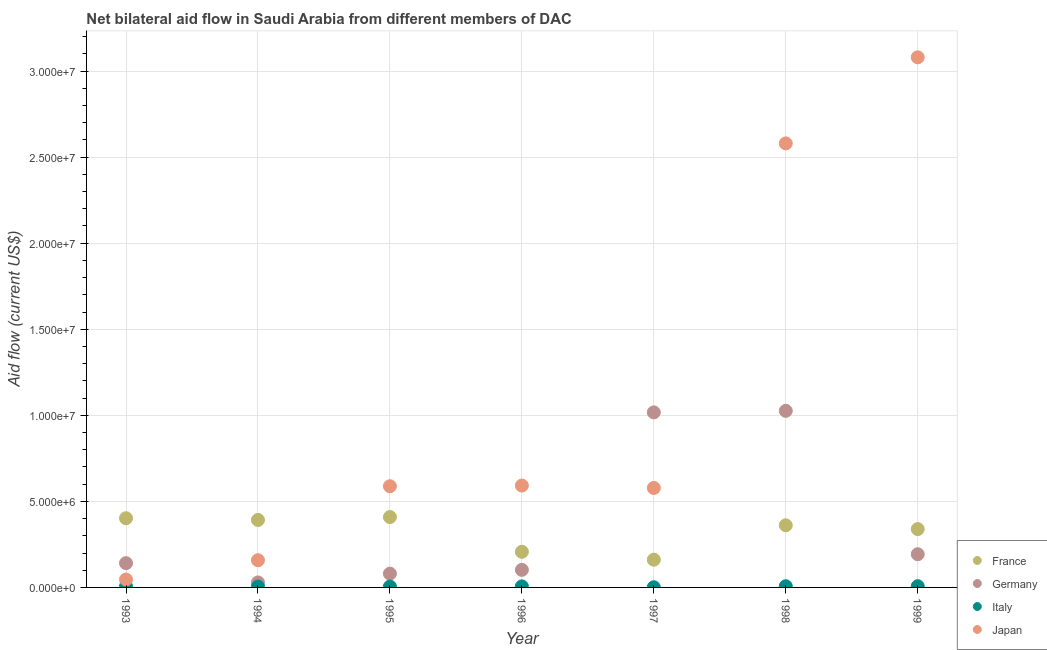How many different coloured dotlines are there?
Your response must be concise. 4. Is the number of dotlines equal to the number of legend labels?
Your answer should be very brief. Yes. What is the amount of aid given by japan in 1999?
Provide a short and direct response. 3.08e+07. Across all years, what is the maximum amount of aid given by germany?
Your answer should be very brief. 1.03e+07. Across all years, what is the minimum amount of aid given by japan?
Give a very brief answer. 4.60e+05. In which year was the amount of aid given by japan minimum?
Provide a short and direct response. 1993. What is the total amount of aid given by japan in the graph?
Ensure brevity in your answer.  7.62e+07. What is the difference between the amount of aid given by france in 1994 and that in 1997?
Give a very brief answer. 2.31e+06. What is the difference between the amount of aid given by germany in 1997 and the amount of aid given by japan in 1996?
Your answer should be compact. 4.25e+06. What is the average amount of aid given by germany per year?
Keep it short and to the point. 3.70e+06. In the year 1995, what is the difference between the amount of aid given by france and amount of aid given by germany?
Offer a very short reply. 3.29e+06. In how many years, is the amount of aid given by italy greater than 28000000 US$?
Your answer should be compact. 0. What is the ratio of the amount of aid given by france in 1995 to that in 1999?
Make the answer very short. 1.21. Is the difference between the amount of aid given by france in 1998 and 1999 greater than the difference between the amount of aid given by japan in 1998 and 1999?
Make the answer very short. Yes. What is the difference between the highest and the second highest amount of aid given by germany?
Keep it short and to the point. 9.00e+04. What is the difference between the highest and the lowest amount of aid given by france?
Offer a terse response. 2.48e+06. Is the sum of the amount of aid given by japan in 1993 and 1999 greater than the maximum amount of aid given by germany across all years?
Your response must be concise. Yes. Is it the case that in every year, the sum of the amount of aid given by germany and amount of aid given by france is greater than the sum of amount of aid given by japan and amount of aid given by italy?
Provide a succinct answer. No. Is it the case that in every year, the sum of the amount of aid given by france and amount of aid given by germany is greater than the amount of aid given by italy?
Provide a succinct answer. Yes. Is the amount of aid given by japan strictly greater than the amount of aid given by france over the years?
Make the answer very short. No. Is the amount of aid given by germany strictly less than the amount of aid given by italy over the years?
Offer a terse response. No. What is the difference between two consecutive major ticks on the Y-axis?
Ensure brevity in your answer.  5.00e+06. Are the values on the major ticks of Y-axis written in scientific E-notation?
Provide a short and direct response. Yes. Does the graph contain grids?
Give a very brief answer. Yes. How are the legend labels stacked?
Keep it short and to the point. Vertical. What is the title of the graph?
Provide a short and direct response. Net bilateral aid flow in Saudi Arabia from different members of DAC. Does "Grants and Revenue" appear as one of the legend labels in the graph?
Offer a terse response. No. What is the Aid flow (current US$) of France in 1993?
Make the answer very short. 4.02e+06. What is the Aid flow (current US$) of Germany in 1993?
Provide a short and direct response. 1.41e+06. What is the Aid flow (current US$) of Italy in 1993?
Your response must be concise. 6.00e+04. What is the Aid flow (current US$) in France in 1994?
Give a very brief answer. 3.92e+06. What is the Aid flow (current US$) in Italy in 1994?
Make the answer very short. 5.00e+04. What is the Aid flow (current US$) of Japan in 1994?
Your response must be concise. 1.58e+06. What is the Aid flow (current US$) of France in 1995?
Your response must be concise. 4.09e+06. What is the Aid flow (current US$) in Japan in 1995?
Make the answer very short. 5.88e+06. What is the Aid flow (current US$) of France in 1996?
Your answer should be compact. 2.07e+06. What is the Aid flow (current US$) in Germany in 1996?
Your answer should be very brief. 1.02e+06. What is the Aid flow (current US$) in Japan in 1996?
Ensure brevity in your answer.  5.92e+06. What is the Aid flow (current US$) of France in 1997?
Offer a very short reply. 1.61e+06. What is the Aid flow (current US$) in Germany in 1997?
Make the answer very short. 1.02e+07. What is the Aid flow (current US$) in Japan in 1997?
Keep it short and to the point. 5.78e+06. What is the Aid flow (current US$) in France in 1998?
Provide a succinct answer. 3.61e+06. What is the Aid flow (current US$) in Germany in 1998?
Give a very brief answer. 1.03e+07. What is the Aid flow (current US$) in Italy in 1998?
Give a very brief answer. 7.00e+04. What is the Aid flow (current US$) in Japan in 1998?
Your answer should be compact. 2.58e+07. What is the Aid flow (current US$) of France in 1999?
Your answer should be very brief. 3.39e+06. What is the Aid flow (current US$) in Germany in 1999?
Your answer should be very brief. 1.93e+06. What is the Aid flow (current US$) in Italy in 1999?
Make the answer very short. 7.00e+04. What is the Aid flow (current US$) of Japan in 1999?
Your response must be concise. 3.08e+07. Across all years, what is the maximum Aid flow (current US$) in France?
Make the answer very short. 4.09e+06. Across all years, what is the maximum Aid flow (current US$) of Germany?
Keep it short and to the point. 1.03e+07. Across all years, what is the maximum Aid flow (current US$) in Italy?
Keep it short and to the point. 7.00e+04. Across all years, what is the maximum Aid flow (current US$) in Japan?
Provide a short and direct response. 3.08e+07. Across all years, what is the minimum Aid flow (current US$) in France?
Give a very brief answer. 1.61e+06. Across all years, what is the minimum Aid flow (current US$) of Germany?
Offer a very short reply. 2.90e+05. Across all years, what is the minimum Aid flow (current US$) of Japan?
Offer a terse response. 4.60e+05. What is the total Aid flow (current US$) in France in the graph?
Offer a terse response. 2.27e+07. What is the total Aid flow (current US$) in Germany in the graph?
Provide a short and direct response. 2.59e+07. What is the total Aid flow (current US$) of Japan in the graph?
Your answer should be compact. 7.62e+07. What is the difference between the Aid flow (current US$) of France in 1993 and that in 1994?
Your answer should be compact. 1.00e+05. What is the difference between the Aid flow (current US$) of Germany in 1993 and that in 1994?
Your answer should be compact. 1.12e+06. What is the difference between the Aid flow (current US$) in Italy in 1993 and that in 1994?
Keep it short and to the point. 10000. What is the difference between the Aid flow (current US$) of Japan in 1993 and that in 1994?
Keep it short and to the point. -1.12e+06. What is the difference between the Aid flow (current US$) in France in 1993 and that in 1995?
Make the answer very short. -7.00e+04. What is the difference between the Aid flow (current US$) of Germany in 1993 and that in 1995?
Your answer should be very brief. 6.10e+05. What is the difference between the Aid flow (current US$) in Italy in 1993 and that in 1995?
Make the answer very short. 10000. What is the difference between the Aid flow (current US$) in Japan in 1993 and that in 1995?
Give a very brief answer. -5.42e+06. What is the difference between the Aid flow (current US$) in France in 1993 and that in 1996?
Provide a short and direct response. 1.95e+06. What is the difference between the Aid flow (current US$) in Germany in 1993 and that in 1996?
Make the answer very short. 3.90e+05. What is the difference between the Aid flow (current US$) in Japan in 1993 and that in 1996?
Your answer should be compact. -5.46e+06. What is the difference between the Aid flow (current US$) in France in 1993 and that in 1997?
Your response must be concise. 2.41e+06. What is the difference between the Aid flow (current US$) of Germany in 1993 and that in 1997?
Your answer should be very brief. -8.76e+06. What is the difference between the Aid flow (current US$) of Japan in 1993 and that in 1997?
Your response must be concise. -5.32e+06. What is the difference between the Aid flow (current US$) of France in 1993 and that in 1998?
Give a very brief answer. 4.10e+05. What is the difference between the Aid flow (current US$) in Germany in 1993 and that in 1998?
Give a very brief answer. -8.85e+06. What is the difference between the Aid flow (current US$) of Italy in 1993 and that in 1998?
Ensure brevity in your answer.  -10000. What is the difference between the Aid flow (current US$) in Japan in 1993 and that in 1998?
Provide a short and direct response. -2.53e+07. What is the difference between the Aid flow (current US$) in France in 1993 and that in 1999?
Provide a succinct answer. 6.30e+05. What is the difference between the Aid flow (current US$) in Germany in 1993 and that in 1999?
Your answer should be compact. -5.20e+05. What is the difference between the Aid flow (current US$) of Italy in 1993 and that in 1999?
Keep it short and to the point. -10000. What is the difference between the Aid flow (current US$) in Japan in 1993 and that in 1999?
Your response must be concise. -3.03e+07. What is the difference between the Aid flow (current US$) of Germany in 1994 and that in 1995?
Make the answer very short. -5.10e+05. What is the difference between the Aid flow (current US$) of Japan in 1994 and that in 1995?
Your answer should be very brief. -4.30e+06. What is the difference between the Aid flow (current US$) in France in 1994 and that in 1996?
Offer a terse response. 1.85e+06. What is the difference between the Aid flow (current US$) in Germany in 1994 and that in 1996?
Give a very brief answer. -7.30e+05. What is the difference between the Aid flow (current US$) in Japan in 1994 and that in 1996?
Provide a succinct answer. -4.34e+06. What is the difference between the Aid flow (current US$) of France in 1994 and that in 1997?
Your response must be concise. 2.31e+06. What is the difference between the Aid flow (current US$) of Germany in 1994 and that in 1997?
Offer a terse response. -9.88e+06. What is the difference between the Aid flow (current US$) in Italy in 1994 and that in 1997?
Your response must be concise. 4.00e+04. What is the difference between the Aid flow (current US$) of Japan in 1994 and that in 1997?
Make the answer very short. -4.20e+06. What is the difference between the Aid flow (current US$) in France in 1994 and that in 1998?
Make the answer very short. 3.10e+05. What is the difference between the Aid flow (current US$) in Germany in 1994 and that in 1998?
Provide a succinct answer. -9.97e+06. What is the difference between the Aid flow (current US$) of Italy in 1994 and that in 1998?
Your answer should be very brief. -2.00e+04. What is the difference between the Aid flow (current US$) in Japan in 1994 and that in 1998?
Ensure brevity in your answer.  -2.42e+07. What is the difference between the Aid flow (current US$) of France in 1994 and that in 1999?
Your response must be concise. 5.30e+05. What is the difference between the Aid flow (current US$) in Germany in 1994 and that in 1999?
Offer a very short reply. -1.64e+06. What is the difference between the Aid flow (current US$) in Japan in 1994 and that in 1999?
Make the answer very short. -2.92e+07. What is the difference between the Aid flow (current US$) in France in 1995 and that in 1996?
Ensure brevity in your answer.  2.02e+06. What is the difference between the Aid flow (current US$) in Germany in 1995 and that in 1996?
Your answer should be very brief. -2.20e+05. What is the difference between the Aid flow (current US$) in Italy in 1995 and that in 1996?
Offer a terse response. -10000. What is the difference between the Aid flow (current US$) of France in 1995 and that in 1997?
Your response must be concise. 2.48e+06. What is the difference between the Aid flow (current US$) of Germany in 1995 and that in 1997?
Provide a short and direct response. -9.37e+06. What is the difference between the Aid flow (current US$) in France in 1995 and that in 1998?
Your response must be concise. 4.80e+05. What is the difference between the Aid flow (current US$) of Germany in 1995 and that in 1998?
Your answer should be compact. -9.46e+06. What is the difference between the Aid flow (current US$) of Italy in 1995 and that in 1998?
Your answer should be very brief. -2.00e+04. What is the difference between the Aid flow (current US$) in Japan in 1995 and that in 1998?
Offer a very short reply. -1.99e+07. What is the difference between the Aid flow (current US$) in France in 1995 and that in 1999?
Ensure brevity in your answer.  7.00e+05. What is the difference between the Aid flow (current US$) of Germany in 1995 and that in 1999?
Provide a short and direct response. -1.13e+06. What is the difference between the Aid flow (current US$) in Italy in 1995 and that in 1999?
Give a very brief answer. -2.00e+04. What is the difference between the Aid flow (current US$) in Japan in 1995 and that in 1999?
Make the answer very short. -2.49e+07. What is the difference between the Aid flow (current US$) in Germany in 1996 and that in 1997?
Offer a terse response. -9.15e+06. What is the difference between the Aid flow (current US$) in Italy in 1996 and that in 1997?
Your answer should be very brief. 5.00e+04. What is the difference between the Aid flow (current US$) of France in 1996 and that in 1998?
Ensure brevity in your answer.  -1.54e+06. What is the difference between the Aid flow (current US$) in Germany in 1996 and that in 1998?
Your answer should be very brief. -9.24e+06. What is the difference between the Aid flow (current US$) of Japan in 1996 and that in 1998?
Your response must be concise. -1.99e+07. What is the difference between the Aid flow (current US$) in France in 1996 and that in 1999?
Ensure brevity in your answer.  -1.32e+06. What is the difference between the Aid flow (current US$) in Germany in 1996 and that in 1999?
Offer a terse response. -9.10e+05. What is the difference between the Aid flow (current US$) in Japan in 1996 and that in 1999?
Offer a terse response. -2.49e+07. What is the difference between the Aid flow (current US$) in France in 1997 and that in 1998?
Provide a succinct answer. -2.00e+06. What is the difference between the Aid flow (current US$) in Germany in 1997 and that in 1998?
Your answer should be very brief. -9.00e+04. What is the difference between the Aid flow (current US$) in Italy in 1997 and that in 1998?
Your answer should be very brief. -6.00e+04. What is the difference between the Aid flow (current US$) of Japan in 1997 and that in 1998?
Offer a very short reply. -2.00e+07. What is the difference between the Aid flow (current US$) of France in 1997 and that in 1999?
Your answer should be very brief. -1.78e+06. What is the difference between the Aid flow (current US$) in Germany in 1997 and that in 1999?
Your answer should be very brief. 8.24e+06. What is the difference between the Aid flow (current US$) of Japan in 1997 and that in 1999?
Your answer should be very brief. -2.50e+07. What is the difference between the Aid flow (current US$) of France in 1998 and that in 1999?
Give a very brief answer. 2.20e+05. What is the difference between the Aid flow (current US$) of Germany in 1998 and that in 1999?
Give a very brief answer. 8.33e+06. What is the difference between the Aid flow (current US$) of Japan in 1998 and that in 1999?
Your response must be concise. -5.00e+06. What is the difference between the Aid flow (current US$) in France in 1993 and the Aid flow (current US$) in Germany in 1994?
Ensure brevity in your answer.  3.73e+06. What is the difference between the Aid flow (current US$) in France in 1993 and the Aid flow (current US$) in Italy in 1994?
Offer a very short reply. 3.97e+06. What is the difference between the Aid flow (current US$) of France in 1993 and the Aid flow (current US$) of Japan in 1994?
Your answer should be compact. 2.44e+06. What is the difference between the Aid flow (current US$) in Germany in 1993 and the Aid flow (current US$) in Italy in 1994?
Ensure brevity in your answer.  1.36e+06. What is the difference between the Aid flow (current US$) of Germany in 1993 and the Aid flow (current US$) of Japan in 1994?
Make the answer very short. -1.70e+05. What is the difference between the Aid flow (current US$) in Italy in 1993 and the Aid flow (current US$) in Japan in 1994?
Your response must be concise. -1.52e+06. What is the difference between the Aid flow (current US$) of France in 1993 and the Aid flow (current US$) of Germany in 1995?
Your answer should be very brief. 3.22e+06. What is the difference between the Aid flow (current US$) in France in 1993 and the Aid flow (current US$) in Italy in 1995?
Your answer should be very brief. 3.97e+06. What is the difference between the Aid flow (current US$) in France in 1993 and the Aid flow (current US$) in Japan in 1995?
Offer a terse response. -1.86e+06. What is the difference between the Aid flow (current US$) in Germany in 1993 and the Aid flow (current US$) in Italy in 1995?
Offer a very short reply. 1.36e+06. What is the difference between the Aid flow (current US$) in Germany in 1993 and the Aid flow (current US$) in Japan in 1995?
Your answer should be very brief. -4.47e+06. What is the difference between the Aid flow (current US$) of Italy in 1993 and the Aid flow (current US$) of Japan in 1995?
Provide a succinct answer. -5.82e+06. What is the difference between the Aid flow (current US$) in France in 1993 and the Aid flow (current US$) in Italy in 1996?
Offer a very short reply. 3.96e+06. What is the difference between the Aid flow (current US$) in France in 1993 and the Aid flow (current US$) in Japan in 1996?
Provide a succinct answer. -1.90e+06. What is the difference between the Aid flow (current US$) in Germany in 1993 and the Aid flow (current US$) in Italy in 1996?
Ensure brevity in your answer.  1.35e+06. What is the difference between the Aid flow (current US$) of Germany in 1993 and the Aid flow (current US$) of Japan in 1996?
Offer a very short reply. -4.51e+06. What is the difference between the Aid flow (current US$) in Italy in 1993 and the Aid flow (current US$) in Japan in 1996?
Provide a succinct answer. -5.86e+06. What is the difference between the Aid flow (current US$) of France in 1993 and the Aid flow (current US$) of Germany in 1997?
Keep it short and to the point. -6.15e+06. What is the difference between the Aid flow (current US$) in France in 1993 and the Aid flow (current US$) in Italy in 1997?
Keep it short and to the point. 4.01e+06. What is the difference between the Aid flow (current US$) in France in 1993 and the Aid flow (current US$) in Japan in 1997?
Keep it short and to the point. -1.76e+06. What is the difference between the Aid flow (current US$) in Germany in 1993 and the Aid flow (current US$) in Italy in 1997?
Your answer should be very brief. 1.40e+06. What is the difference between the Aid flow (current US$) of Germany in 1993 and the Aid flow (current US$) of Japan in 1997?
Your answer should be very brief. -4.37e+06. What is the difference between the Aid flow (current US$) in Italy in 1993 and the Aid flow (current US$) in Japan in 1997?
Keep it short and to the point. -5.72e+06. What is the difference between the Aid flow (current US$) of France in 1993 and the Aid flow (current US$) of Germany in 1998?
Offer a terse response. -6.24e+06. What is the difference between the Aid flow (current US$) in France in 1993 and the Aid flow (current US$) in Italy in 1998?
Provide a short and direct response. 3.95e+06. What is the difference between the Aid flow (current US$) of France in 1993 and the Aid flow (current US$) of Japan in 1998?
Offer a very short reply. -2.18e+07. What is the difference between the Aid flow (current US$) of Germany in 1993 and the Aid flow (current US$) of Italy in 1998?
Ensure brevity in your answer.  1.34e+06. What is the difference between the Aid flow (current US$) of Germany in 1993 and the Aid flow (current US$) of Japan in 1998?
Make the answer very short. -2.44e+07. What is the difference between the Aid flow (current US$) of Italy in 1993 and the Aid flow (current US$) of Japan in 1998?
Give a very brief answer. -2.57e+07. What is the difference between the Aid flow (current US$) in France in 1993 and the Aid flow (current US$) in Germany in 1999?
Provide a short and direct response. 2.09e+06. What is the difference between the Aid flow (current US$) of France in 1993 and the Aid flow (current US$) of Italy in 1999?
Offer a very short reply. 3.95e+06. What is the difference between the Aid flow (current US$) in France in 1993 and the Aid flow (current US$) in Japan in 1999?
Provide a short and direct response. -2.68e+07. What is the difference between the Aid flow (current US$) in Germany in 1993 and the Aid flow (current US$) in Italy in 1999?
Your answer should be compact. 1.34e+06. What is the difference between the Aid flow (current US$) in Germany in 1993 and the Aid flow (current US$) in Japan in 1999?
Your response must be concise. -2.94e+07. What is the difference between the Aid flow (current US$) of Italy in 1993 and the Aid flow (current US$) of Japan in 1999?
Offer a terse response. -3.07e+07. What is the difference between the Aid flow (current US$) of France in 1994 and the Aid flow (current US$) of Germany in 1995?
Provide a succinct answer. 3.12e+06. What is the difference between the Aid flow (current US$) of France in 1994 and the Aid flow (current US$) of Italy in 1995?
Provide a short and direct response. 3.87e+06. What is the difference between the Aid flow (current US$) in France in 1994 and the Aid flow (current US$) in Japan in 1995?
Your response must be concise. -1.96e+06. What is the difference between the Aid flow (current US$) of Germany in 1994 and the Aid flow (current US$) of Japan in 1995?
Ensure brevity in your answer.  -5.59e+06. What is the difference between the Aid flow (current US$) of Italy in 1994 and the Aid flow (current US$) of Japan in 1995?
Give a very brief answer. -5.83e+06. What is the difference between the Aid flow (current US$) of France in 1994 and the Aid flow (current US$) of Germany in 1996?
Offer a very short reply. 2.90e+06. What is the difference between the Aid flow (current US$) of France in 1994 and the Aid flow (current US$) of Italy in 1996?
Keep it short and to the point. 3.86e+06. What is the difference between the Aid flow (current US$) in France in 1994 and the Aid flow (current US$) in Japan in 1996?
Keep it short and to the point. -2.00e+06. What is the difference between the Aid flow (current US$) of Germany in 1994 and the Aid flow (current US$) of Italy in 1996?
Give a very brief answer. 2.30e+05. What is the difference between the Aid flow (current US$) of Germany in 1994 and the Aid flow (current US$) of Japan in 1996?
Keep it short and to the point. -5.63e+06. What is the difference between the Aid flow (current US$) of Italy in 1994 and the Aid flow (current US$) of Japan in 1996?
Your answer should be compact. -5.87e+06. What is the difference between the Aid flow (current US$) of France in 1994 and the Aid flow (current US$) of Germany in 1997?
Your answer should be compact. -6.25e+06. What is the difference between the Aid flow (current US$) in France in 1994 and the Aid flow (current US$) in Italy in 1997?
Provide a succinct answer. 3.91e+06. What is the difference between the Aid flow (current US$) in France in 1994 and the Aid flow (current US$) in Japan in 1997?
Offer a very short reply. -1.86e+06. What is the difference between the Aid flow (current US$) of Germany in 1994 and the Aid flow (current US$) of Italy in 1997?
Your response must be concise. 2.80e+05. What is the difference between the Aid flow (current US$) of Germany in 1994 and the Aid flow (current US$) of Japan in 1997?
Keep it short and to the point. -5.49e+06. What is the difference between the Aid flow (current US$) in Italy in 1994 and the Aid flow (current US$) in Japan in 1997?
Provide a succinct answer. -5.73e+06. What is the difference between the Aid flow (current US$) of France in 1994 and the Aid flow (current US$) of Germany in 1998?
Give a very brief answer. -6.34e+06. What is the difference between the Aid flow (current US$) of France in 1994 and the Aid flow (current US$) of Italy in 1998?
Offer a terse response. 3.85e+06. What is the difference between the Aid flow (current US$) in France in 1994 and the Aid flow (current US$) in Japan in 1998?
Give a very brief answer. -2.19e+07. What is the difference between the Aid flow (current US$) in Germany in 1994 and the Aid flow (current US$) in Japan in 1998?
Your answer should be very brief. -2.55e+07. What is the difference between the Aid flow (current US$) in Italy in 1994 and the Aid flow (current US$) in Japan in 1998?
Keep it short and to the point. -2.58e+07. What is the difference between the Aid flow (current US$) of France in 1994 and the Aid flow (current US$) of Germany in 1999?
Offer a terse response. 1.99e+06. What is the difference between the Aid flow (current US$) of France in 1994 and the Aid flow (current US$) of Italy in 1999?
Ensure brevity in your answer.  3.85e+06. What is the difference between the Aid flow (current US$) of France in 1994 and the Aid flow (current US$) of Japan in 1999?
Make the answer very short. -2.69e+07. What is the difference between the Aid flow (current US$) in Germany in 1994 and the Aid flow (current US$) in Japan in 1999?
Provide a succinct answer. -3.05e+07. What is the difference between the Aid flow (current US$) in Italy in 1994 and the Aid flow (current US$) in Japan in 1999?
Your response must be concise. -3.08e+07. What is the difference between the Aid flow (current US$) of France in 1995 and the Aid flow (current US$) of Germany in 1996?
Make the answer very short. 3.07e+06. What is the difference between the Aid flow (current US$) in France in 1995 and the Aid flow (current US$) in Italy in 1996?
Your answer should be compact. 4.03e+06. What is the difference between the Aid flow (current US$) of France in 1995 and the Aid flow (current US$) of Japan in 1996?
Ensure brevity in your answer.  -1.83e+06. What is the difference between the Aid flow (current US$) of Germany in 1995 and the Aid flow (current US$) of Italy in 1996?
Your response must be concise. 7.40e+05. What is the difference between the Aid flow (current US$) of Germany in 1995 and the Aid flow (current US$) of Japan in 1996?
Ensure brevity in your answer.  -5.12e+06. What is the difference between the Aid flow (current US$) in Italy in 1995 and the Aid flow (current US$) in Japan in 1996?
Offer a very short reply. -5.87e+06. What is the difference between the Aid flow (current US$) of France in 1995 and the Aid flow (current US$) of Germany in 1997?
Provide a short and direct response. -6.08e+06. What is the difference between the Aid flow (current US$) in France in 1995 and the Aid flow (current US$) in Italy in 1997?
Ensure brevity in your answer.  4.08e+06. What is the difference between the Aid flow (current US$) in France in 1995 and the Aid flow (current US$) in Japan in 1997?
Ensure brevity in your answer.  -1.69e+06. What is the difference between the Aid flow (current US$) of Germany in 1995 and the Aid flow (current US$) of Italy in 1997?
Keep it short and to the point. 7.90e+05. What is the difference between the Aid flow (current US$) in Germany in 1995 and the Aid flow (current US$) in Japan in 1997?
Make the answer very short. -4.98e+06. What is the difference between the Aid flow (current US$) of Italy in 1995 and the Aid flow (current US$) of Japan in 1997?
Offer a very short reply. -5.73e+06. What is the difference between the Aid flow (current US$) of France in 1995 and the Aid flow (current US$) of Germany in 1998?
Offer a terse response. -6.17e+06. What is the difference between the Aid flow (current US$) in France in 1995 and the Aid flow (current US$) in Italy in 1998?
Provide a succinct answer. 4.02e+06. What is the difference between the Aid flow (current US$) of France in 1995 and the Aid flow (current US$) of Japan in 1998?
Your response must be concise. -2.17e+07. What is the difference between the Aid flow (current US$) in Germany in 1995 and the Aid flow (current US$) in Italy in 1998?
Your answer should be compact. 7.30e+05. What is the difference between the Aid flow (current US$) in Germany in 1995 and the Aid flow (current US$) in Japan in 1998?
Ensure brevity in your answer.  -2.50e+07. What is the difference between the Aid flow (current US$) of Italy in 1995 and the Aid flow (current US$) of Japan in 1998?
Your answer should be compact. -2.58e+07. What is the difference between the Aid flow (current US$) in France in 1995 and the Aid flow (current US$) in Germany in 1999?
Make the answer very short. 2.16e+06. What is the difference between the Aid flow (current US$) in France in 1995 and the Aid flow (current US$) in Italy in 1999?
Your response must be concise. 4.02e+06. What is the difference between the Aid flow (current US$) in France in 1995 and the Aid flow (current US$) in Japan in 1999?
Keep it short and to the point. -2.67e+07. What is the difference between the Aid flow (current US$) in Germany in 1995 and the Aid flow (current US$) in Italy in 1999?
Provide a succinct answer. 7.30e+05. What is the difference between the Aid flow (current US$) in Germany in 1995 and the Aid flow (current US$) in Japan in 1999?
Ensure brevity in your answer.  -3.00e+07. What is the difference between the Aid flow (current US$) of Italy in 1995 and the Aid flow (current US$) of Japan in 1999?
Make the answer very short. -3.08e+07. What is the difference between the Aid flow (current US$) in France in 1996 and the Aid flow (current US$) in Germany in 1997?
Give a very brief answer. -8.10e+06. What is the difference between the Aid flow (current US$) in France in 1996 and the Aid flow (current US$) in Italy in 1997?
Your answer should be compact. 2.06e+06. What is the difference between the Aid flow (current US$) of France in 1996 and the Aid flow (current US$) of Japan in 1997?
Your response must be concise. -3.71e+06. What is the difference between the Aid flow (current US$) of Germany in 1996 and the Aid flow (current US$) of Italy in 1997?
Ensure brevity in your answer.  1.01e+06. What is the difference between the Aid flow (current US$) in Germany in 1996 and the Aid flow (current US$) in Japan in 1997?
Provide a short and direct response. -4.76e+06. What is the difference between the Aid flow (current US$) in Italy in 1996 and the Aid flow (current US$) in Japan in 1997?
Offer a terse response. -5.72e+06. What is the difference between the Aid flow (current US$) of France in 1996 and the Aid flow (current US$) of Germany in 1998?
Keep it short and to the point. -8.19e+06. What is the difference between the Aid flow (current US$) in France in 1996 and the Aid flow (current US$) in Japan in 1998?
Ensure brevity in your answer.  -2.37e+07. What is the difference between the Aid flow (current US$) in Germany in 1996 and the Aid flow (current US$) in Italy in 1998?
Keep it short and to the point. 9.50e+05. What is the difference between the Aid flow (current US$) of Germany in 1996 and the Aid flow (current US$) of Japan in 1998?
Offer a very short reply. -2.48e+07. What is the difference between the Aid flow (current US$) in Italy in 1996 and the Aid flow (current US$) in Japan in 1998?
Ensure brevity in your answer.  -2.57e+07. What is the difference between the Aid flow (current US$) of France in 1996 and the Aid flow (current US$) of Italy in 1999?
Your answer should be very brief. 2.00e+06. What is the difference between the Aid flow (current US$) in France in 1996 and the Aid flow (current US$) in Japan in 1999?
Offer a very short reply. -2.87e+07. What is the difference between the Aid flow (current US$) in Germany in 1996 and the Aid flow (current US$) in Italy in 1999?
Your answer should be compact. 9.50e+05. What is the difference between the Aid flow (current US$) in Germany in 1996 and the Aid flow (current US$) in Japan in 1999?
Give a very brief answer. -2.98e+07. What is the difference between the Aid flow (current US$) in Italy in 1996 and the Aid flow (current US$) in Japan in 1999?
Your answer should be compact. -3.07e+07. What is the difference between the Aid flow (current US$) in France in 1997 and the Aid flow (current US$) in Germany in 1998?
Your answer should be compact. -8.65e+06. What is the difference between the Aid flow (current US$) of France in 1997 and the Aid flow (current US$) of Italy in 1998?
Offer a terse response. 1.54e+06. What is the difference between the Aid flow (current US$) in France in 1997 and the Aid flow (current US$) in Japan in 1998?
Your answer should be compact. -2.42e+07. What is the difference between the Aid flow (current US$) of Germany in 1997 and the Aid flow (current US$) of Italy in 1998?
Keep it short and to the point. 1.01e+07. What is the difference between the Aid flow (current US$) in Germany in 1997 and the Aid flow (current US$) in Japan in 1998?
Provide a succinct answer. -1.56e+07. What is the difference between the Aid flow (current US$) of Italy in 1997 and the Aid flow (current US$) of Japan in 1998?
Ensure brevity in your answer.  -2.58e+07. What is the difference between the Aid flow (current US$) of France in 1997 and the Aid flow (current US$) of Germany in 1999?
Ensure brevity in your answer.  -3.20e+05. What is the difference between the Aid flow (current US$) in France in 1997 and the Aid flow (current US$) in Italy in 1999?
Your answer should be very brief. 1.54e+06. What is the difference between the Aid flow (current US$) in France in 1997 and the Aid flow (current US$) in Japan in 1999?
Make the answer very short. -2.92e+07. What is the difference between the Aid flow (current US$) of Germany in 1997 and the Aid flow (current US$) of Italy in 1999?
Keep it short and to the point. 1.01e+07. What is the difference between the Aid flow (current US$) in Germany in 1997 and the Aid flow (current US$) in Japan in 1999?
Provide a succinct answer. -2.06e+07. What is the difference between the Aid flow (current US$) of Italy in 1997 and the Aid flow (current US$) of Japan in 1999?
Make the answer very short. -3.08e+07. What is the difference between the Aid flow (current US$) of France in 1998 and the Aid flow (current US$) of Germany in 1999?
Provide a short and direct response. 1.68e+06. What is the difference between the Aid flow (current US$) in France in 1998 and the Aid flow (current US$) in Italy in 1999?
Make the answer very short. 3.54e+06. What is the difference between the Aid flow (current US$) of France in 1998 and the Aid flow (current US$) of Japan in 1999?
Provide a short and direct response. -2.72e+07. What is the difference between the Aid flow (current US$) in Germany in 1998 and the Aid flow (current US$) in Italy in 1999?
Your answer should be very brief. 1.02e+07. What is the difference between the Aid flow (current US$) in Germany in 1998 and the Aid flow (current US$) in Japan in 1999?
Your response must be concise. -2.05e+07. What is the difference between the Aid flow (current US$) in Italy in 1998 and the Aid flow (current US$) in Japan in 1999?
Ensure brevity in your answer.  -3.07e+07. What is the average Aid flow (current US$) in France per year?
Give a very brief answer. 3.24e+06. What is the average Aid flow (current US$) of Germany per year?
Make the answer very short. 3.70e+06. What is the average Aid flow (current US$) of Italy per year?
Provide a succinct answer. 5.29e+04. What is the average Aid flow (current US$) of Japan per year?
Offer a very short reply. 1.09e+07. In the year 1993, what is the difference between the Aid flow (current US$) in France and Aid flow (current US$) in Germany?
Ensure brevity in your answer.  2.61e+06. In the year 1993, what is the difference between the Aid flow (current US$) in France and Aid flow (current US$) in Italy?
Provide a short and direct response. 3.96e+06. In the year 1993, what is the difference between the Aid flow (current US$) of France and Aid flow (current US$) of Japan?
Offer a terse response. 3.56e+06. In the year 1993, what is the difference between the Aid flow (current US$) of Germany and Aid flow (current US$) of Italy?
Offer a terse response. 1.35e+06. In the year 1993, what is the difference between the Aid flow (current US$) in Germany and Aid flow (current US$) in Japan?
Make the answer very short. 9.50e+05. In the year 1993, what is the difference between the Aid flow (current US$) in Italy and Aid flow (current US$) in Japan?
Your response must be concise. -4.00e+05. In the year 1994, what is the difference between the Aid flow (current US$) in France and Aid flow (current US$) in Germany?
Your answer should be compact. 3.63e+06. In the year 1994, what is the difference between the Aid flow (current US$) of France and Aid flow (current US$) of Italy?
Your answer should be very brief. 3.87e+06. In the year 1994, what is the difference between the Aid flow (current US$) in France and Aid flow (current US$) in Japan?
Provide a short and direct response. 2.34e+06. In the year 1994, what is the difference between the Aid flow (current US$) of Germany and Aid flow (current US$) of Italy?
Your answer should be compact. 2.40e+05. In the year 1994, what is the difference between the Aid flow (current US$) in Germany and Aid flow (current US$) in Japan?
Give a very brief answer. -1.29e+06. In the year 1994, what is the difference between the Aid flow (current US$) of Italy and Aid flow (current US$) of Japan?
Offer a terse response. -1.53e+06. In the year 1995, what is the difference between the Aid flow (current US$) in France and Aid flow (current US$) in Germany?
Your response must be concise. 3.29e+06. In the year 1995, what is the difference between the Aid flow (current US$) in France and Aid flow (current US$) in Italy?
Keep it short and to the point. 4.04e+06. In the year 1995, what is the difference between the Aid flow (current US$) of France and Aid flow (current US$) of Japan?
Ensure brevity in your answer.  -1.79e+06. In the year 1995, what is the difference between the Aid flow (current US$) in Germany and Aid flow (current US$) in Italy?
Make the answer very short. 7.50e+05. In the year 1995, what is the difference between the Aid flow (current US$) in Germany and Aid flow (current US$) in Japan?
Provide a short and direct response. -5.08e+06. In the year 1995, what is the difference between the Aid flow (current US$) in Italy and Aid flow (current US$) in Japan?
Give a very brief answer. -5.83e+06. In the year 1996, what is the difference between the Aid flow (current US$) in France and Aid flow (current US$) in Germany?
Ensure brevity in your answer.  1.05e+06. In the year 1996, what is the difference between the Aid flow (current US$) of France and Aid flow (current US$) of Italy?
Offer a very short reply. 2.01e+06. In the year 1996, what is the difference between the Aid flow (current US$) of France and Aid flow (current US$) of Japan?
Offer a terse response. -3.85e+06. In the year 1996, what is the difference between the Aid flow (current US$) of Germany and Aid flow (current US$) of Italy?
Offer a terse response. 9.60e+05. In the year 1996, what is the difference between the Aid flow (current US$) of Germany and Aid flow (current US$) of Japan?
Your answer should be compact. -4.90e+06. In the year 1996, what is the difference between the Aid flow (current US$) of Italy and Aid flow (current US$) of Japan?
Your answer should be compact. -5.86e+06. In the year 1997, what is the difference between the Aid flow (current US$) in France and Aid flow (current US$) in Germany?
Give a very brief answer. -8.56e+06. In the year 1997, what is the difference between the Aid flow (current US$) in France and Aid flow (current US$) in Italy?
Ensure brevity in your answer.  1.60e+06. In the year 1997, what is the difference between the Aid flow (current US$) in France and Aid flow (current US$) in Japan?
Make the answer very short. -4.17e+06. In the year 1997, what is the difference between the Aid flow (current US$) of Germany and Aid flow (current US$) of Italy?
Your response must be concise. 1.02e+07. In the year 1997, what is the difference between the Aid flow (current US$) in Germany and Aid flow (current US$) in Japan?
Make the answer very short. 4.39e+06. In the year 1997, what is the difference between the Aid flow (current US$) of Italy and Aid flow (current US$) of Japan?
Provide a succinct answer. -5.77e+06. In the year 1998, what is the difference between the Aid flow (current US$) of France and Aid flow (current US$) of Germany?
Keep it short and to the point. -6.65e+06. In the year 1998, what is the difference between the Aid flow (current US$) in France and Aid flow (current US$) in Italy?
Your answer should be compact. 3.54e+06. In the year 1998, what is the difference between the Aid flow (current US$) in France and Aid flow (current US$) in Japan?
Ensure brevity in your answer.  -2.22e+07. In the year 1998, what is the difference between the Aid flow (current US$) of Germany and Aid flow (current US$) of Italy?
Your answer should be very brief. 1.02e+07. In the year 1998, what is the difference between the Aid flow (current US$) of Germany and Aid flow (current US$) of Japan?
Make the answer very short. -1.55e+07. In the year 1998, what is the difference between the Aid flow (current US$) of Italy and Aid flow (current US$) of Japan?
Your answer should be compact. -2.57e+07. In the year 1999, what is the difference between the Aid flow (current US$) of France and Aid flow (current US$) of Germany?
Give a very brief answer. 1.46e+06. In the year 1999, what is the difference between the Aid flow (current US$) of France and Aid flow (current US$) of Italy?
Your response must be concise. 3.32e+06. In the year 1999, what is the difference between the Aid flow (current US$) in France and Aid flow (current US$) in Japan?
Make the answer very short. -2.74e+07. In the year 1999, what is the difference between the Aid flow (current US$) of Germany and Aid flow (current US$) of Italy?
Your answer should be very brief. 1.86e+06. In the year 1999, what is the difference between the Aid flow (current US$) in Germany and Aid flow (current US$) in Japan?
Keep it short and to the point. -2.89e+07. In the year 1999, what is the difference between the Aid flow (current US$) in Italy and Aid flow (current US$) in Japan?
Ensure brevity in your answer.  -3.07e+07. What is the ratio of the Aid flow (current US$) in France in 1993 to that in 1994?
Your response must be concise. 1.03. What is the ratio of the Aid flow (current US$) of Germany in 1993 to that in 1994?
Your response must be concise. 4.86. What is the ratio of the Aid flow (current US$) of Japan in 1993 to that in 1994?
Provide a short and direct response. 0.29. What is the ratio of the Aid flow (current US$) in France in 1993 to that in 1995?
Offer a terse response. 0.98. What is the ratio of the Aid flow (current US$) in Germany in 1993 to that in 1995?
Provide a succinct answer. 1.76. What is the ratio of the Aid flow (current US$) of Italy in 1993 to that in 1995?
Ensure brevity in your answer.  1.2. What is the ratio of the Aid flow (current US$) in Japan in 1993 to that in 1995?
Provide a short and direct response. 0.08. What is the ratio of the Aid flow (current US$) in France in 1993 to that in 1996?
Give a very brief answer. 1.94. What is the ratio of the Aid flow (current US$) of Germany in 1993 to that in 1996?
Your response must be concise. 1.38. What is the ratio of the Aid flow (current US$) of Italy in 1993 to that in 1996?
Offer a terse response. 1. What is the ratio of the Aid flow (current US$) in Japan in 1993 to that in 1996?
Your answer should be very brief. 0.08. What is the ratio of the Aid flow (current US$) in France in 1993 to that in 1997?
Your answer should be very brief. 2.5. What is the ratio of the Aid flow (current US$) in Germany in 1993 to that in 1997?
Provide a short and direct response. 0.14. What is the ratio of the Aid flow (current US$) in Japan in 1993 to that in 1997?
Your answer should be very brief. 0.08. What is the ratio of the Aid flow (current US$) of France in 1993 to that in 1998?
Make the answer very short. 1.11. What is the ratio of the Aid flow (current US$) of Germany in 1993 to that in 1998?
Keep it short and to the point. 0.14. What is the ratio of the Aid flow (current US$) in Japan in 1993 to that in 1998?
Your answer should be very brief. 0.02. What is the ratio of the Aid flow (current US$) in France in 1993 to that in 1999?
Ensure brevity in your answer.  1.19. What is the ratio of the Aid flow (current US$) in Germany in 1993 to that in 1999?
Your answer should be compact. 0.73. What is the ratio of the Aid flow (current US$) of Italy in 1993 to that in 1999?
Ensure brevity in your answer.  0.86. What is the ratio of the Aid flow (current US$) of Japan in 1993 to that in 1999?
Provide a succinct answer. 0.01. What is the ratio of the Aid flow (current US$) in France in 1994 to that in 1995?
Your answer should be very brief. 0.96. What is the ratio of the Aid flow (current US$) in Germany in 1994 to that in 1995?
Your answer should be very brief. 0.36. What is the ratio of the Aid flow (current US$) of Italy in 1994 to that in 1995?
Provide a short and direct response. 1. What is the ratio of the Aid flow (current US$) of Japan in 1994 to that in 1995?
Provide a short and direct response. 0.27. What is the ratio of the Aid flow (current US$) in France in 1994 to that in 1996?
Your answer should be compact. 1.89. What is the ratio of the Aid flow (current US$) in Germany in 1994 to that in 1996?
Offer a terse response. 0.28. What is the ratio of the Aid flow (current US$) of Italy in 1994 to that in 1996?
Offer a very short reply. 0.83. What is the ratio of the Aid flow (current US$) in Japan in 1994 to that in 1996?
Provide a succinct answer. 0.27. What is the ratio of the Aid flow (current US$) of France in 1994 to that in 1997?
Give a very brief answer. 2.43. What is the ratio of the Aid flow (current US$) of Germany in 1994 to that in 1997?
Your answer should be very brief. 0.03. What is the ratio of the Aid flow (current US$) in Japan in 1994 to that in 1997?
Provide a short and direct response. 0.27. What is the ratio of the Aid flow (current US$) in France in 1994 to that in 1998?
Keep it short and to the point. 1.09. What is the ratio of the Aid flow (current US$) in Germany in 1994 to that in 1998?
Make the answer very short. 0.03. What is the ratio of the Aid flow (current US$) in Japan in 1994 to that in 1998?
Offer a terse response. 0.06. What is the ratio of the Aid flow (current US$) in France in 1994 to that in 1999?
Offer a terse response. 1.16. What is the ratio of the Aid flow (current US$) of Germany in 1994 to that in 1999?
Your response must be concise. 0.15. What is the ratio of the Aid flow (current US$) in Japan in 1994 to that in 1999?
Offer a terse response. 0.05. What is the ratio of the Aid flow (current US$) of France in 1995 to that in 1996?
Offer a very short reply. 1.98. What is the ratio of the Aid flow (current US$) of Germany in 1995 to that in 1996?
Your answer should be very brief. 0.78. What is the ratio of the Aid flow (current US$) of Italy in 1995 to that in 1996?
Keep it short and to the point. 0.83. What is the ratio of the Aid flow (current US$) of Japan in 1995 to that in 1996?
Your response must be concise. 0.99. What is the ratio of the Aid flow (current US$) in France in 1995 to that in 1997?
Offer a terse response. 2.54. What is the ratio of the Aid flow (current US$) in Germany in 1995 to that in 1997?
Offer a very short reply. 0.08. What is the ratio of the Aid flow (current US$) of Italy in 1995 to that in 1997?
Ensure brevity in your answer.  5. What is the ratio of the Aid flow (current US$) in Japan in 1995 to that in 1997?
Make the answer very short. 1.02. What is the ratio of the Aid flow (current US$) in France in 1995 to that in 1998?
Provide a short and direct response. 1.13. What is the ratio of the Aid flow (current US$) of Germany in 1995 to that in 1998?
Provide a short and direct response. 0.08. What is the ratio of the Aid flow (current US$) in Italy in 1995 to that in 1998?
Provide a succinct answer. 0.71. What is the ratio of the Aid flow (current US$) of Japan in 1995 to that in 1998?
Keep it short and to the point. 0.23. What is the ratio of the Aid flow (current US$) of France in 1995 to that in 1999?
Provide a short and direct response. 1.21. What is the ratio of the Aid flow (current US$) in Germany in 1995 to that in 1999?
Make the answer very short. 0.41. What is the ratio of the Aid flow (current US$) in Japan in 1995 to that in 1999?
Provide a succinct answer. 0.19. What is the ratio of the Aid flow (current US$) in Germany in 1996 to that in 1997?
Make the answer very short. 0.1. What is the ratio of the Aid flow (current US$) of Italy in 1996 to that in 1997?
Keep it short and to the point. 6. What is the ratio of the Aid flow (current US$) in Japan in 1996 to that in 1997?
Your answer should be compact. 1.02. What is the ratio of the Aid flow (current US$) of France in 1996 to that in 1998?
Provide a succinct answer. 0.57. What is the ratio of the Aid flow (current US$) in Germany in 1996 to that in 1998?
Give a very brief answer. 0.1. What is the ratio of the Aid flow (current US$) of Italy in 1996 to that in 1998?
Give a very brief answer. 0.86. What is the ratio of the Aid flow (current US$) of Japan in 1996 to that in 1998?
Your response must be concise. 0.23. What is the ratio of the Aid flow (current US$) of France in 1996 to that in 1999?
Your answer should be compact. 0.61. What is the ratio of the Aid flow (current US$) in Germany in 1996 to that in 1999?
Your answer should be compact. 0.53. What is the ratio of the Aid flow (current US$) of Japan in 1996 to that in 1999?
Offer a very short reply. 0.19. What is the ratio of the Aid flow (current US$) of France in 1997 to that in 1998?
Offer a very short reply. 0.45. What is the ratio of the Aid flow (current US$) of Italy in 1997 to that in 1998?
Keep it short and to the point. 0.14. What is the ratio of the Aid flow (current US$) of Japan in 1997 to that in 1998?
Provide a short and direct response. 0.22. What is the ratio of the Aid flow (current US$) of France in 1997 to that in 1999?
Your answer should be very brief. 0.47. What is the ratio of the Aid flow (current US$) of Germany in 1997 to that in 1999?
Give a very brief answer. 5.27. What is the ratio of the Aid flow (current US$) in Italy in 1997 to that in 1999?
Provide a short and direct response. 0.14. What is the ratio of the Aid flow (current US$) in Japan in 1997 to that in 1999?
Give a very brief answer. 0.19. What is the ratio of the Aid flow (current US$) of France in 1998 to that in 1999?
Your answer should be very brief. 1.06. What is the ratio of the Aid flow (current US$) in Germany in 1998 to that in 1999?
Offer a very short reply. 5.32. What is the ratio of the Aid flow (current US$) in Italy in 1998 to that in 1999?
Keep it short and to the point. 1. What is the ratio of the Aid flow (current US$) in Japan in 1998 to that in 1999?
Make the answer very short. 0.84. What is the difference between the highest and the second highest Aid flow (current US$) of France?
Ensure brevity in your answer.  7.00e+04. What is the difference between the highest and the lowest Aid flow (current US$) in France?
Offer a terse response. 2.48e+06. What is the difference between the highest and the lowest Aid flow (current US$) in Germany?
Your response must be concise. 9.97e+06. What is the difference between the highest and the lowest Aid flow (current US$) of Italy?
Your response must be concise. 6.00e+04. What is the difference between the highest and the lowest Aid flow (current US$) of Japan?
Make the answer very short. 3.03e+07. 